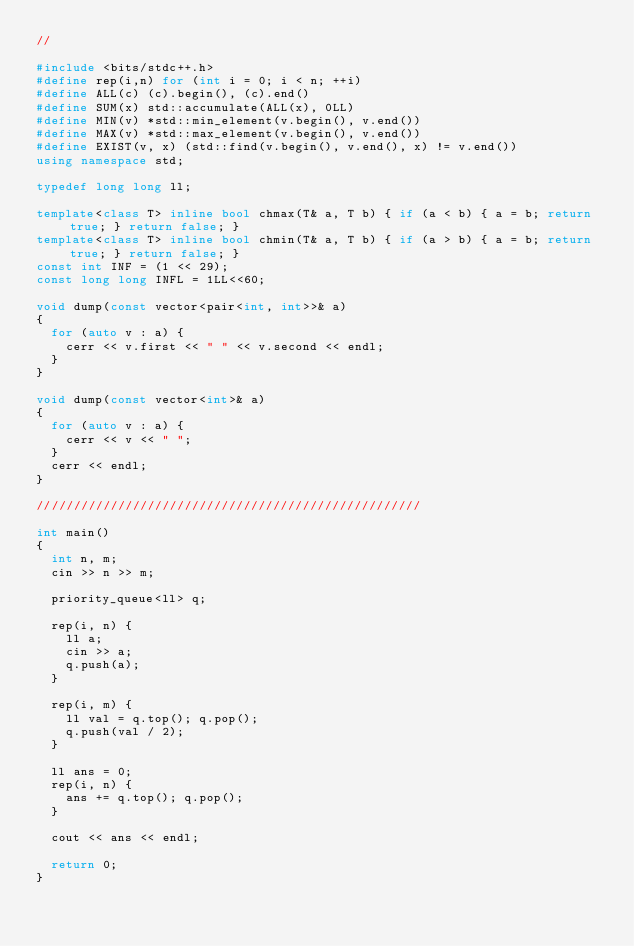<code> <loc_0><loc_0><loc_500><loc_500><_C++_>// 

#include <bits/stdc++.h>
#define rep(i,n) for (int i = 0; i < n; ++i)
#define ALL(c) (c).begin(), (c).end()
#define SUM(x) std::accumulate(ALL(x), 0LL)
#define MIN(v) *std::min_element(v.begin(), v.end())
#define MAX(v) *std::max_element(v.begin(), v.end())
#define EXIST(v, x) (std::find(v.begin(), v.end(), x) != v.end())
using namespace std;

typedef long long ll;

template<class T> inline bool chmax(T& a, T b) { if (a < b) { a = b; return true; } return false; }
template<class T> inline bool chmin(T& a, T b) { if (a > b) { a = b; return true; } return false; }
const int INF = (1 << 29);
const long long INFL = 1LL<<60;

void dump(const vector<pair<int, int>>& a)
{
  for (auto v : a) {
    cerr << v.first << " " << v.second << endl;
  }
}

void dump(const vector<int>& a)
{
  for (auto v : a) {
    cerr << v << " ";
  }
  cerr << endl;
}

////////////////////////////////////////////////////

int main()
{
  int n, m;
  cin >> n >> m;

  priority_queue<ll> q;

  rep(i, n) {
    ll a;
    cin >> a;
    q.push(a);
  }

  rep(i, m) {
    ll val = q.top(); q.pop();
    q.push(val / 2);
  }

  ll ans = 0;
  rep(i, n) {
    ans += q.top(); q.pop();
  }

  cout << ans << endl;

  return 0;
}
</code> 